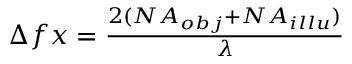<formula> <loc_0><loc_0><loc_500><loc_500>\begin{array} { r } { \Delta f x = \frac { 2 ( N A _ { o b j } + N A _ { i l l u } ) } { \lambda } } \end{array}</formula> 